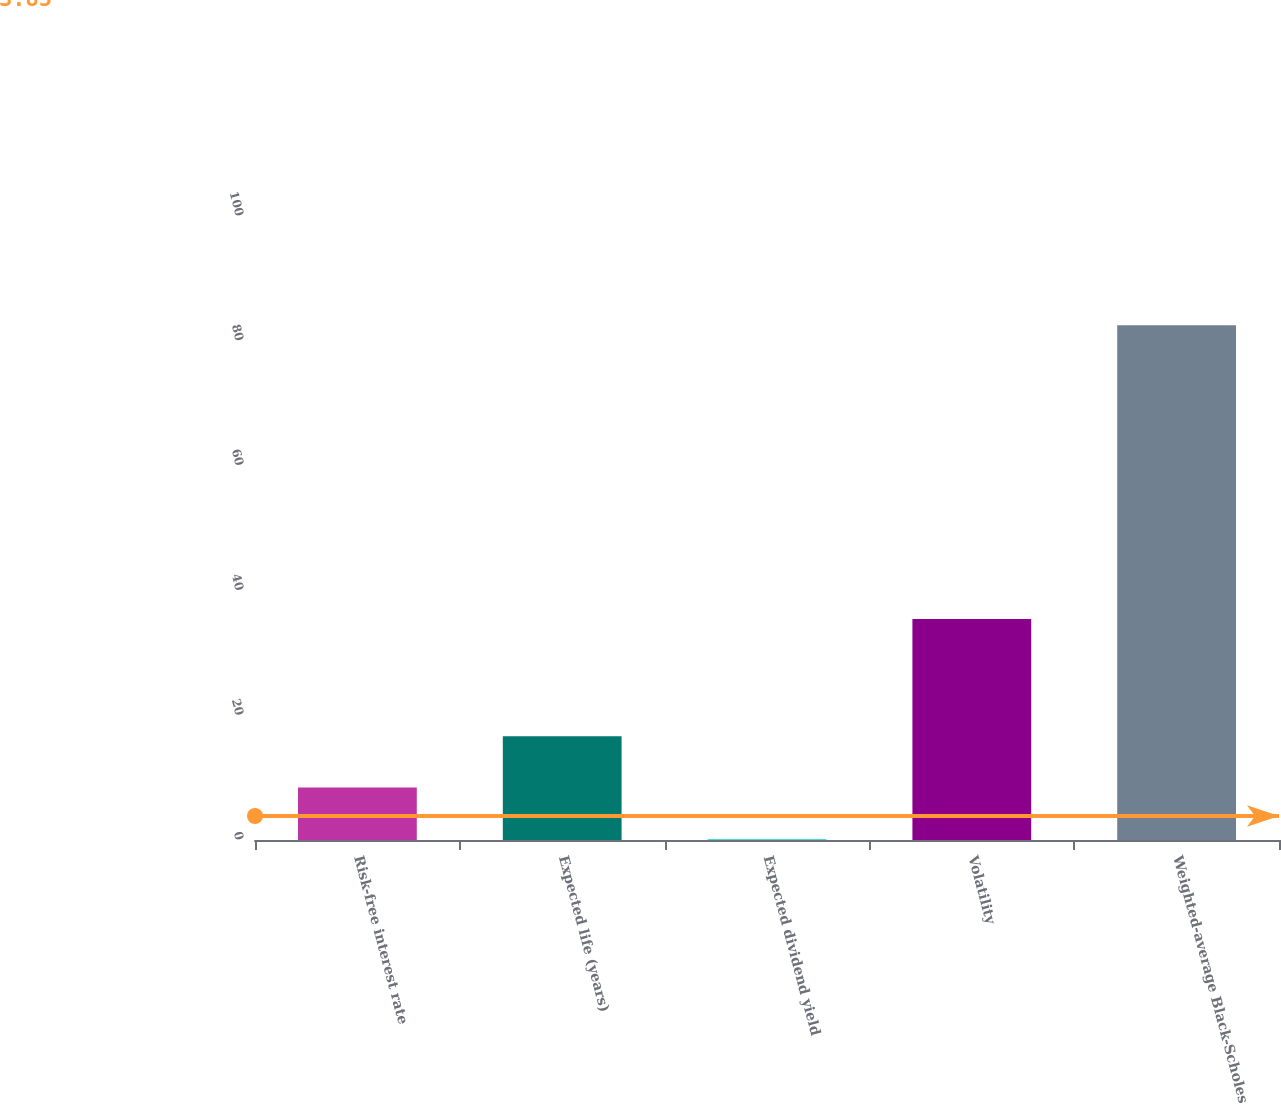<chart> <loc_0><loc_0><loc_500><loc_500><bar_chart><fcel>Risk-free interest rate<fcel>Expected life (years)<fcel>Expected dividend yield<fcel>Volatility<fcel>Weighted-average Black-Scholes<nl><fcel>8.41<fcel>16.64<fcel>0.18<fcel>35.4<fcel>82.51<nl></chart> 